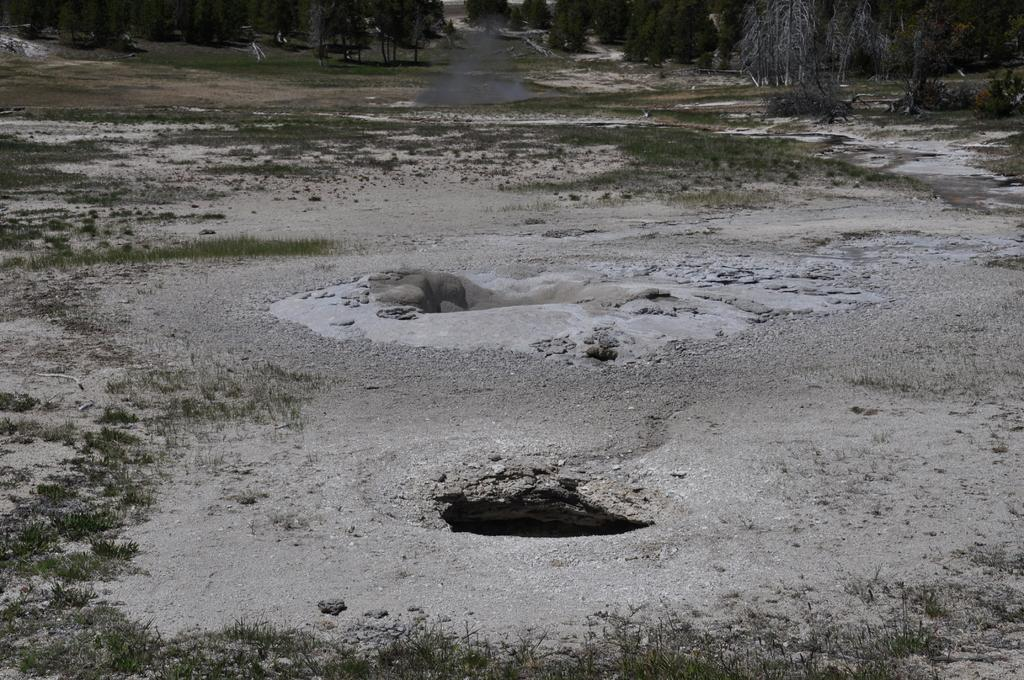What can be seen in the ground in the image? There are holes in the ground in the image. What type of vegetation is present in the image? There are trees in the image. What type of ground cover is visible in the image? There is grass on the ground in the image. Can you see a chain connecting the trees in the image? There is no chain connecting the trees in the image; only trees, holes in the ground, and grass are present. Is there a lake visible in the image? There is no lake present in the image; it features trees, holes in the ground, and grass. 